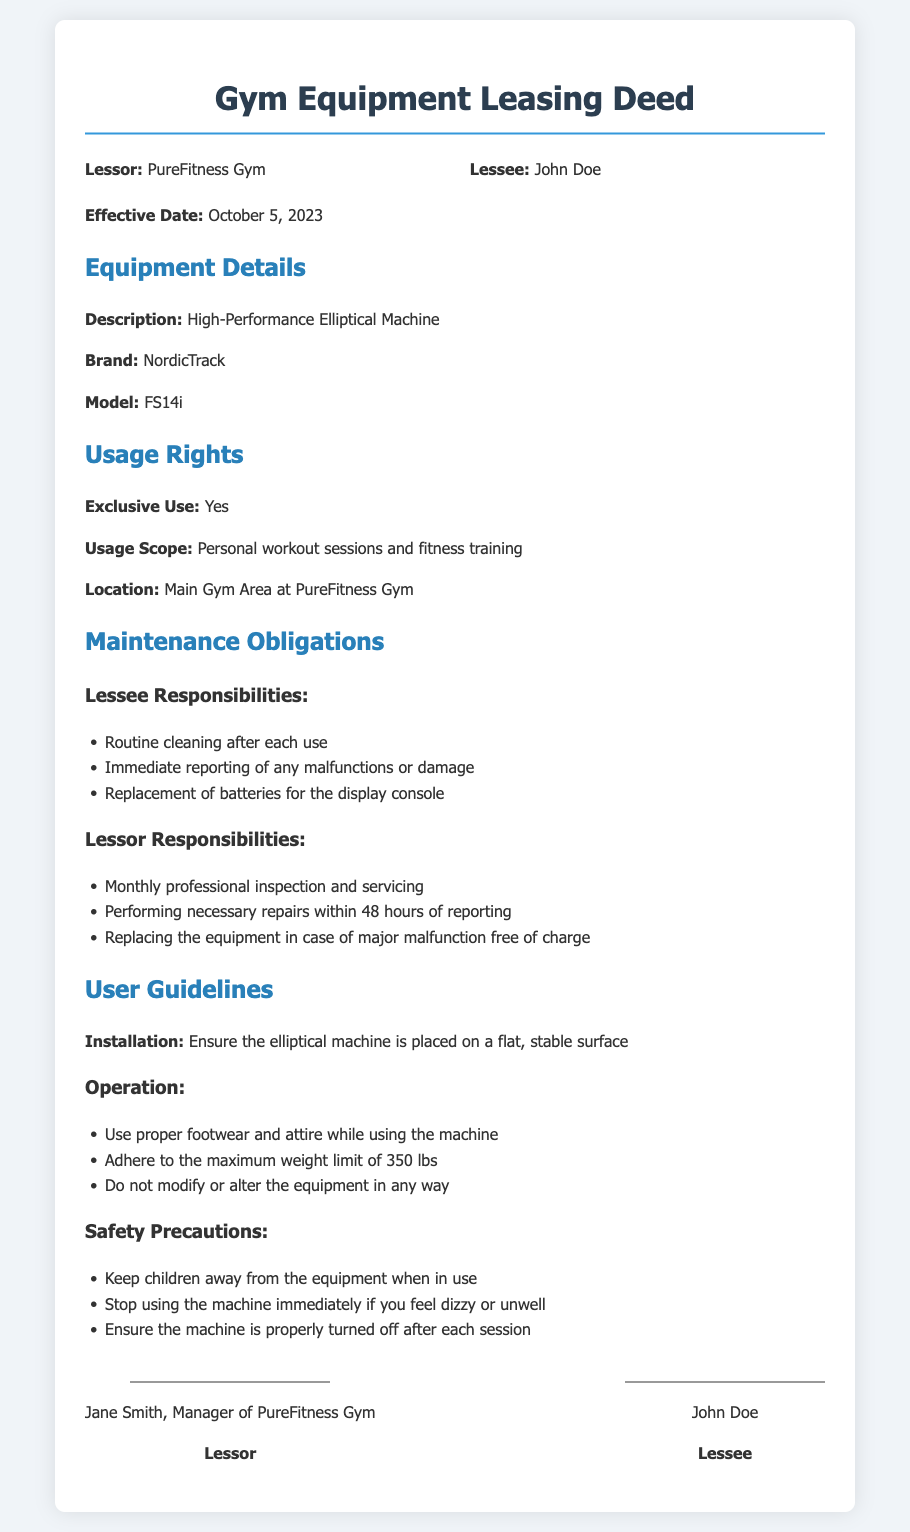What is the effective date of the deed? The effective date is stated in the document, indicating when the lease begins.
Answer: October 5, 2023 Who is the lessee? The lessee's name is provided in the document, identifying the person who is leasing the equipment.
Answer: John Doe What type of equipment is being leased? The description of the equipment is mentioned in the document, providing specific details about it.
Answer: High-Performance Elliptical Machine What is the maximum weight limit for the elliptical machine? The document specifies a maximum weight limit to ensure safety during use.
Answer: 350 lbs What must the lessee do after each use of the equipment? The responsibilities of the lessee include specific actions they must take regarding maintenance.
Answer: Routine cleaning after each use How quickly must the lessor perform repairs after a malfunction is reported? The document outlines the timeline for the lessor's response to maintenance issues.
Answer: Within 48 hours Where should the equipment be installed? The guidelines provide important information on the placement of the equipment for safety and effectiveness.
Answer: On a flat, stable surface What should be done if someone feels unwell while using the equipment? The safety precautions indicate actions to take if a user experiences discomfort during use.
Answer: Stop using the machine immediately What is the brand of the elliptical machine? The document contains specific details about the equipment, including its brand.
Answer: NordicTrack 